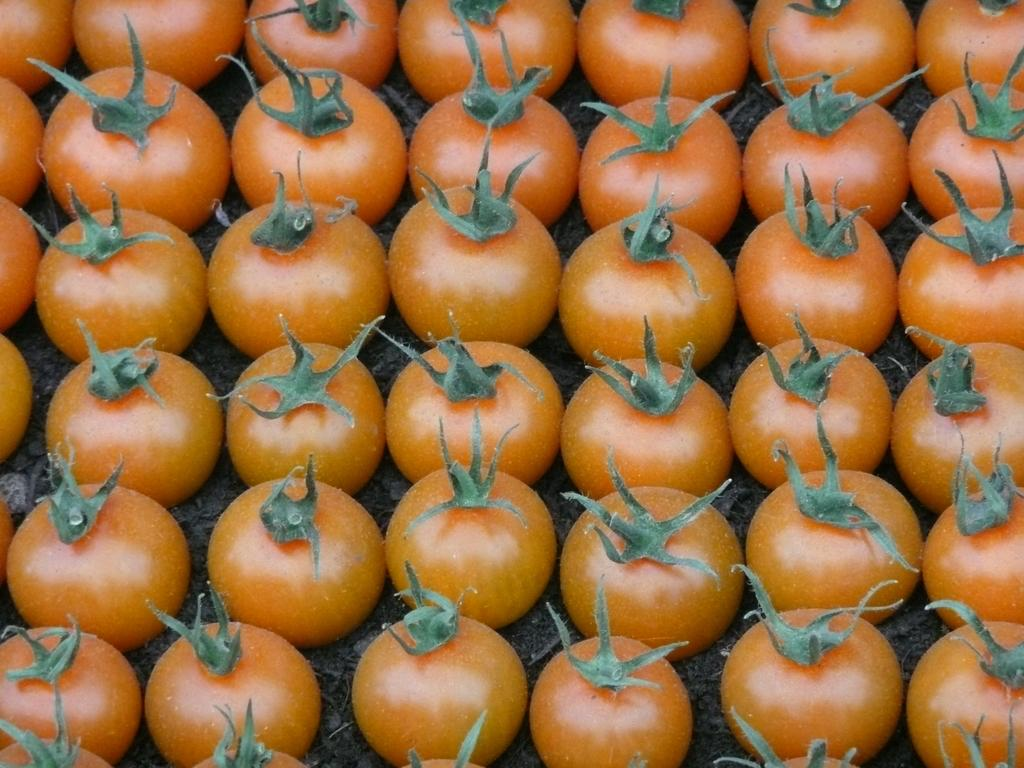What type of fruit can be seen in the image? There are tomatoes in the image. Where are the tomatoes located in the image? The tomatoes are placed on the ground. What type of comfort can be seen in the image? There is no comfort present in the image; it features tomatoes placed on the ground. What type of tax is being discussed in the image? There is no discussion of tax in the image; it features tomatoes placed on the ground. 